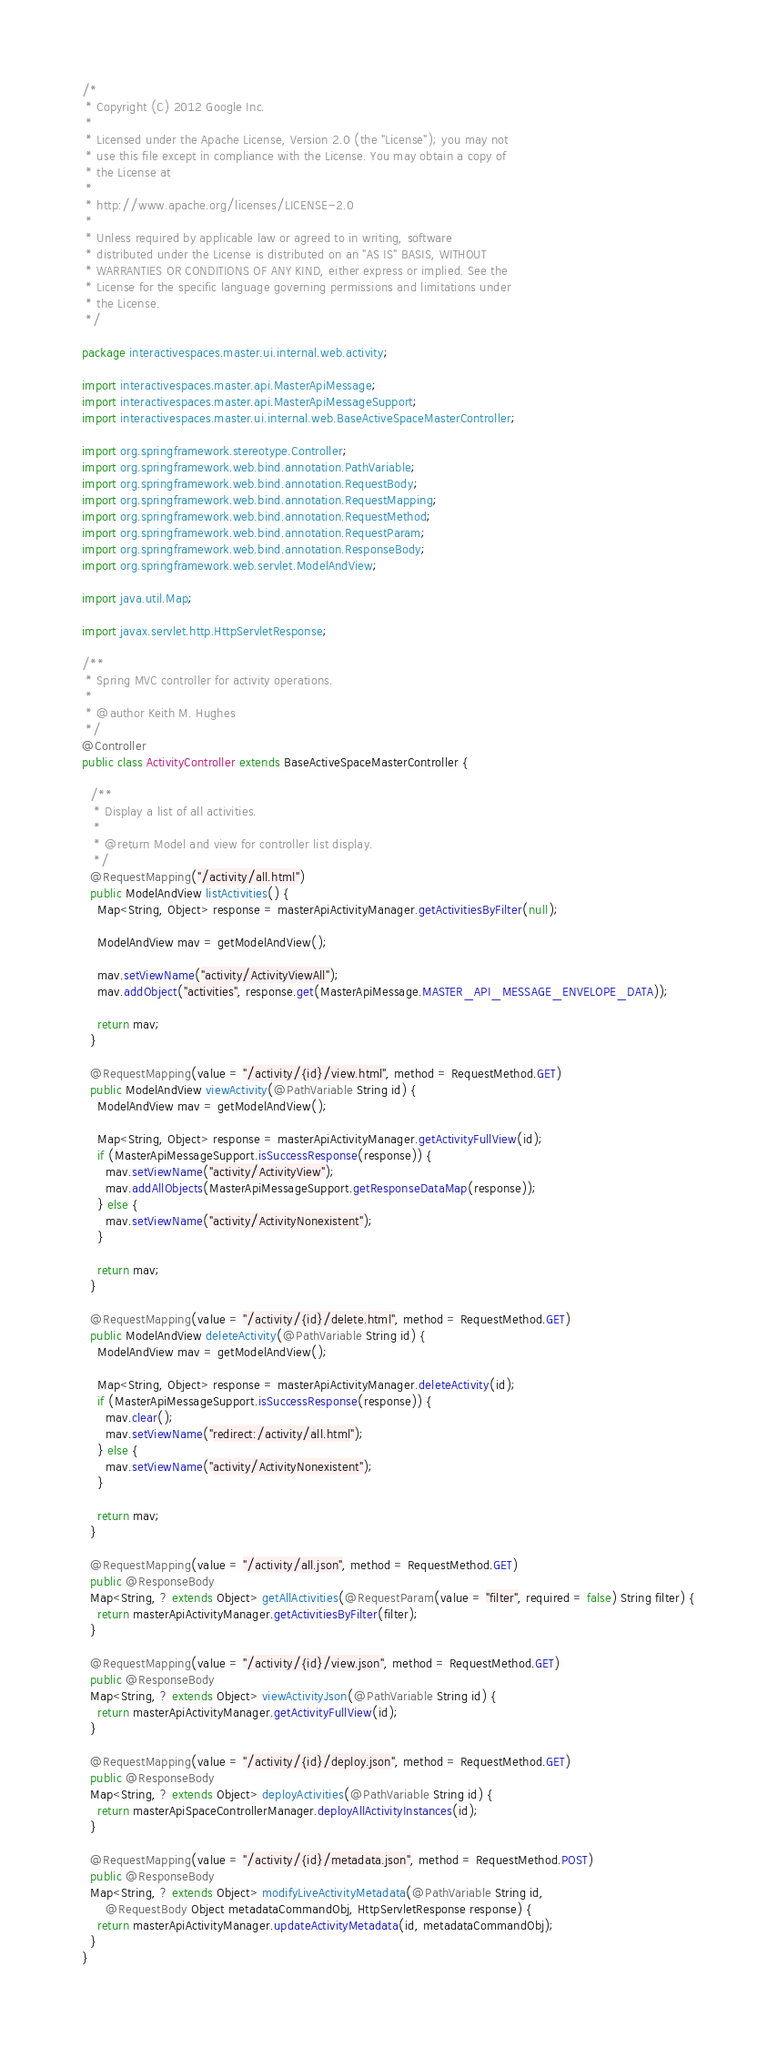<code> <loc_0><loc_0><loc_500><loc_500><_Java_>/*
 * Copyright (C) 2012 Google Inc.
 *
 * Licensed under the Apache License, Version 2.0 (the "License"); you may not
 * use this file except in compliance with the License. You may obtain a copy of
 * the License at
 *
 * http://www.apache.org/licenses/LICENSE-2.0
 *
 * Unless required by applicable law or agreed to in writing, software
 * distributed under the License is distributed on an "AS IS" BASIS, WITHOUT
 * WARRANTIES OR CONDITIONS OF ANY KIND, either express or implied. See the
 * License for the specific language governing permissions and limitations under
 * the License.
 */

package interactivespaces.master.ui.internal.web.activity;

import interactivespaces.master.api.MasterApiMessage;
import interactivespaces.master.api.MasterApiMessageSupport;
import interactivespaces.master.ui.internal.web.BaseActiveSpaceMasterController;

import org.springframework.stereotype.Controller;
import org.springframework.web.bind.annotation.PathVariable;
import org.springframework.web.bind.annotation.RequestBody;
import org.springframework.web.bind.annotation.RequestMapping;
import org.springframework.web.bind.annotation.RequestMethod;
import org.springframework.web.bind.annotation.RequestParam;
import org.springframework.web.bind.annotation.ResponseBody;
import org.springframework.web.servlet.ModelAndView;

import java.util.Map;

import javax.servlet.http.HttpServletResponse;

/**
 * Spring MVC controller for activity operations.
 *
 * @author Keith M. Hughes
 */
@Controller
public class ActivityController extends BaseActiveSpaceMasterController {

  /**
   * Display a list of all activities.
   *
   * @return Model and view for controller list display.
   */
  @RequestMapping("/activity/all.html")
  public ModelAndView listActivities() {
    Map<String, Object> response = masterApiActivityManager.getActivitiesByFilter(null);

    ModelAndView mav = getModelAndView();

    mav.setViewName("activity/ActivityViewAll");
    mav.addObject("activities", response.get(MasterApiMessage.MASTER_API_MESSAGE_ENVELOPE_DATA));

    return mav;
  }

  @RequestMapping(value = "/activity/{id}/view.html", method = RequestMethod.GET)
  public ModelAndView viewActivity(@PathVariable String id) {
    ModelAndView mav = getModelAndView();

    Map<String, Object> response = masterApiActivityManager.getActivityFullView(id);
    if (MasterApiMessageSupport.isSuccessResponse(response)) {
      mav.setViewName("activity/ActivityView");
      mav.addAllObjects(MasterApiMessageSupport.getResponseDataMap(response));
    } else {
      mav.setViewName("activity/ActivityNonexistent");
    }

    return mav;
  }

  @RequestMapping(value = "/activity/{id}/delete.html", method = RequestMethod.GET)
  public ModelAndView deleteActivity(@PathVariable String id) {
    ModelAndView mav = getModelAndView();

    Map<String, Object> response = masterApiActivityManager.deleteActivity(id);
    if (MasterApiMessageSupport.isSuccessResponse(response)) {
      mav.clear();
      mav.setViewName("redirect:/activity/all.html");
    } else {
      mav.setViewName("activity/ActivityNonexistent");
    }

    return mav;
  }

  @RequestMapping(value = "/activity/all.json", method = RequestMethod.GET)
  public @ResponseBody
  Map<String, ? extends Object> getAllActivities(@RequestParam(value = "filter", required = false) String filter) {
    return masterApiActivityManager.getActivitiesByFilter(filter);
  }

  @RequestMapping(value = "/activity/{id}/view.json", method = RequestMethod.GET)
  public @ResponseBody
  Map<String, ? extends Object> viewActivityJson(@PathVariable String id) {
    return masterApiActivityManager.getActivityFullView(id);
  }

  @RequestMapping(value = "/activity/{id}/deploy.json", method = RequestMethod.GET)
  public @ResponseBody
  Map<String, ? extends Object> deployActivities(@PathVariable String id) {
    return masterApiSpaceControllerManager.deployAllActivityInstances(id);
  }

  @RequestMapping(value = "/activity/{id}/metadata.json", method = RequestMethod.POST)
  public @ResponseBody
  Map<String, ? extends Object> modifyLiveActivityMetadata(@PathVariable String id,
      @RequestBody Object metadataCommandObj, HttpServletResponse response) {
    return masterApiActivityManager.updateActivityMetadata(id, metadataCommandObj);
  }
}
</code> 